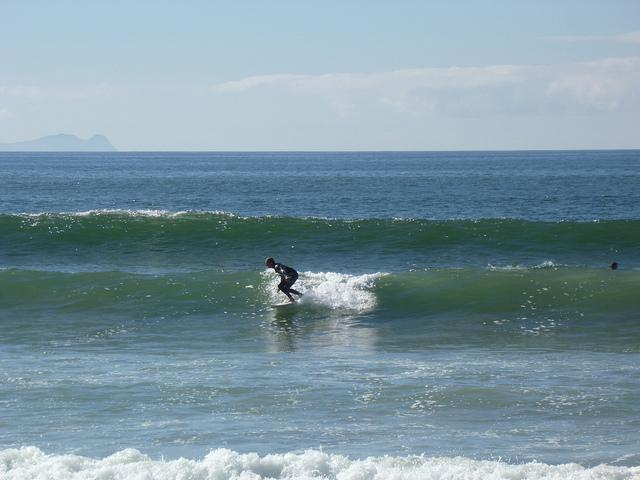What is a term related to this event? Please explain your reasoning. surfs up. The man is surfing in the water. 